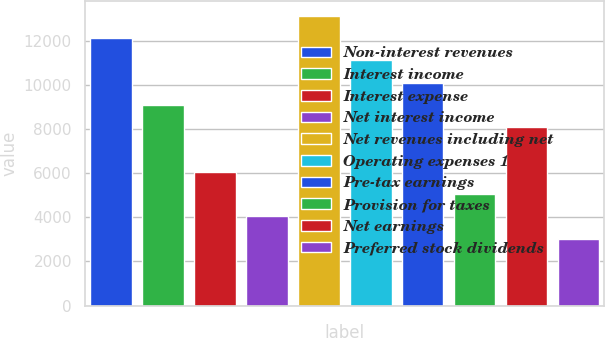Convert chart to OTSL. <chart><loc_0><loc_0><loc_500><loc_500><bar_chart><fcel>Non-interest revenues<fcel>Interest income<fcel>Interest expense<fcel>Net interest income<fcel>Net revenues including net<fcel>Operating expenses 1<fcel>Pre-tax earnings<fcel>Provision for taxes<fcel>Net earnings<fcel>Preferred stock dividends<nl><fcel>12107.9<fcel>9081.05<fcel>6054.2<fcel>4036.3<fcel>13116.9<fcel>11099<fcel>10090<fcel>5045.25<fcel>8072.1<fcel>3027.35<nl></chart> 